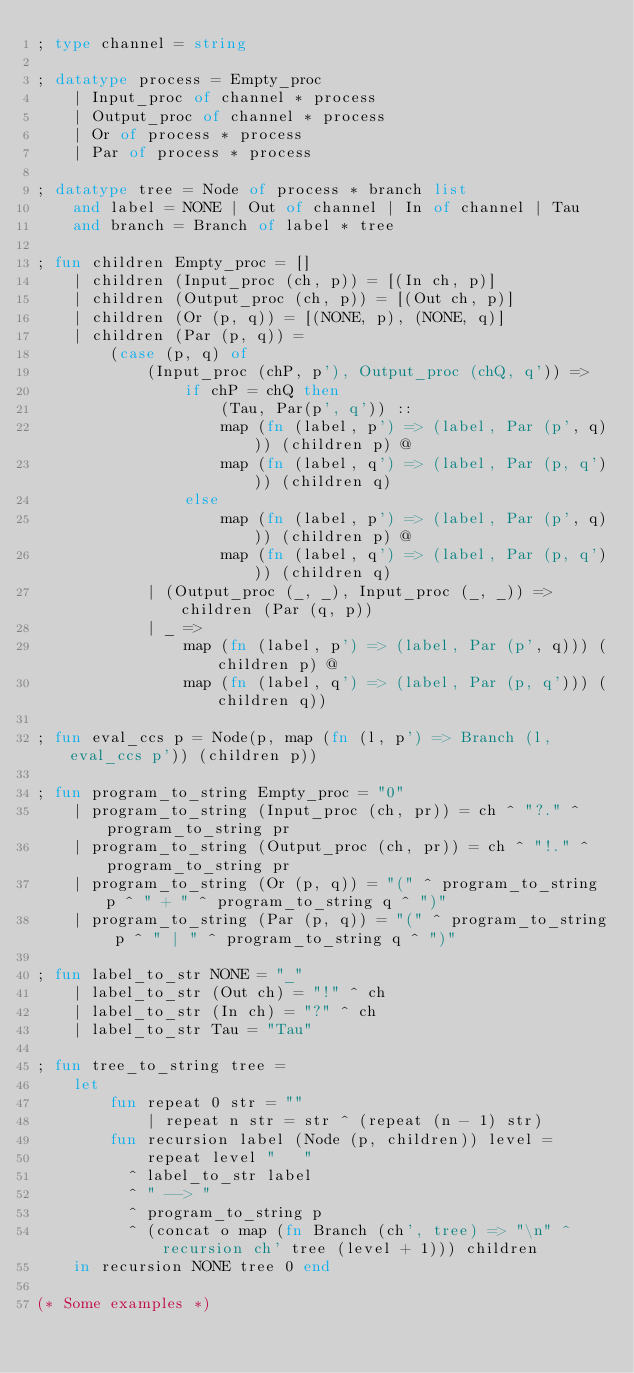Convert code to text. <code><loc_0><loc_0><loc_500><loc_500><_SML_>; type channel = string

; datatype process = Empty_proc
    | Input_proc of channel * process
    | Output_proc of channel * process
    | Or of process * process
    | Par of process * process

; datatype tree = Node of process * branch list
    and label = NONE | Out of channel | In of channel | Tau
    and branch = Branch of label * tree

; fun children Empty_proc = []
    | children (Input_proc (ch, p)) = [(In ch, p)]
    | children (Output_proc (ch, p)) = [(Out ch, p)]
    | children (Or (p, q)) = [(NONE, p), (NONE, q)]
    | children (Par (p, q)) =
        (case (p, q) of
            (Input_proc (chP, p'), Output_proc (chQ, q')) =>
                if chP = chQ then
                    (Tau, Par(p', q')) ::
                    map (fn (label, p') => (label, Par (p', q))) (children p) @
                    map (fn (label, q') => (label, Par (p, q'))) (children q)
                else
                    map (fn (label, p') => (label, Par (p', q))) (children p) @
                    map (fn (label, q') => (label, Par (p, q'))) (children q)
            | (Output_proc (_, _), Input_proc (_, _)) => children (Par (q, p))
            | _ =>
                map (fn (label, p') => (label, Par (p', q))) (children p) @
                map (fn (label, q') => (label, Par (p, q'))) (children q))

; fun eval_ccs p = Node(p, map (fn (l, p') => Branch (l, eval_ccs p')) (children p))

; fun program_to_string Empty_proc = "0"
    | program_to_string (Input_proc (ch, pr)) = ch ^ "?." ^ program_to_string pr
    | program_to_string (Output_proc (ch, pr)) = ch ^ "!." ^ program_to_string pr
    | program_to_string (Or (p, q)) = "(" ^ program_to_string p ^ " + " ^ program_to_string q ^ ")"
    | program_to_string (Par (p, q)) = "(" ^ program_to_string p ^ " | " ^ program_to_string q ^ ")"

; fun label_to_str NONE = "_"
    | label_to_str (Out ch) = "!" ^ ch
    | label_to_str (In ch) = "?" ^ ch
    | label_to_str Tau = "Tau"

; fun tree_to_string tree =
    let
        fun repeat 0 str = ""
            | repeat n str = str ^ (repeat (n - 1) str)
        fun recursion label (Node (p, children)) level =
            repeat level "   "
          ^ label_to_str label 
          ^ " --> "
          ^ program_to_string p
          ^ (concat o map (fn Branch (ch', tree) => "\n" ^ recursion ch' tree (level + 1))) children
    in recursion NONE tree 0 end

(* Some examples *)
</code> 